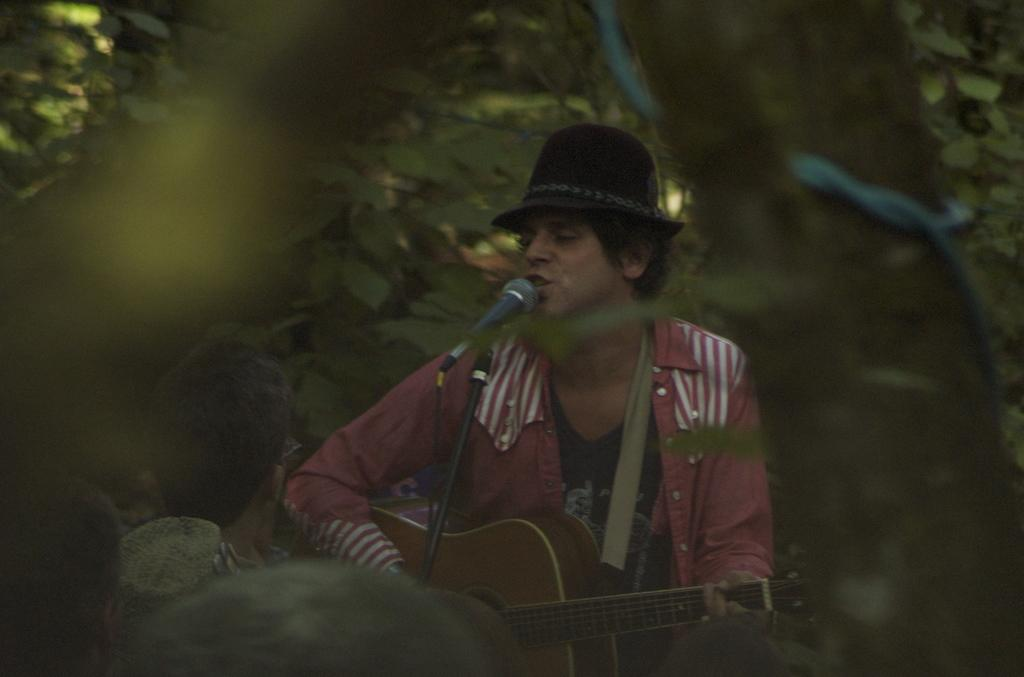What is the man in the image doing? The man is playing the guitar and singing. What object is the man holding in the image? The man is holding a guitar. Where is the man positioned in relation to the microphone? The man is standing in front of a microphone. What can be seen in the background of the image? There are trees in the background of the image. How many ducks are sitting on the orange in the image? There are no ducks or oranges present in the image. What type of school is visible in the background of the image? There is no school visible in the background of the image; it features trees. 